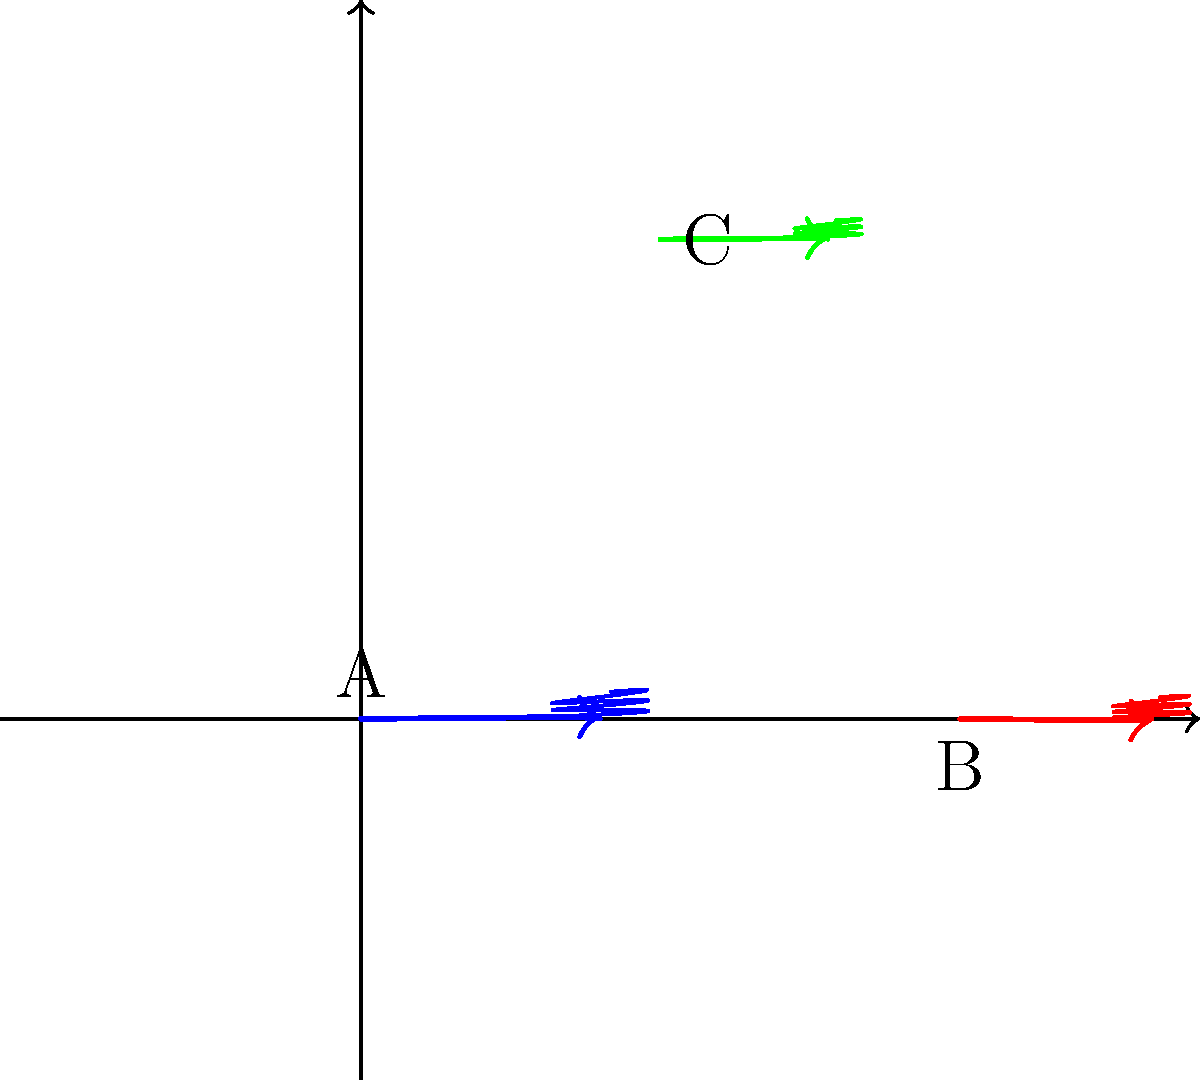In the simulated turbulent flow shown above, three distinct vortices (A, B, and C) are visible. Based on the direction of rotation and relative sizes of these vortices, which of the following statements is most likely true about their vorticity ($\vec{\omega} = \nabla \times \vec{v}$)?

a) Vortex A has the highest magnitude of vorticity.
b) Vortex B has the highest magnitude of vorticity.
c) Vortex C has the highest magnitude of vorticity.
d) All vortices have equal magnitude of vorticity. To determine the relative magnitudes of vorticity for each vortex, we need to consider two factors: the size of the vortex and its rotational speed. In fluid dynamics, vorticity is defined as $\vec{\omega} = \nabla \times \vec{v}$, where $\vec{v}$ is the velocity field.

1. Size consideration: Smaller vortices tend to have higher vorticity magnitudes because the velocity gradients are steeper in a smaller space.

2. Rotational speed: The arrows indicate the direction and relative speed of rotation. Longer arrows suggest faster rotation, which contributes to higher vorticity.

3. Vortex A: Largest size, clockwise rotation, moderate arrow length.
4. Vortex B: Medium size, counterclockwise rotation, longest arrow.
5. Vortex C: Smallest size, clockwise rotation, shortest arrow.

Combining these factors:
- Vortex A has the largest size, which decreases its vorticity, but moderate rotation speed.
- Vortex B has a medium size and the fastest rotation, significantly increasing its vorticity.
- Vortex C has the smallest size, which increases its vorticity, but the slowest rotation.

The combination of medium size and fastest rotation makes Vortex B likely to have the highest magnitude of vorticity among the three vortices.
Answer: b) Vortex B has the highest magnitude of vorticity. 